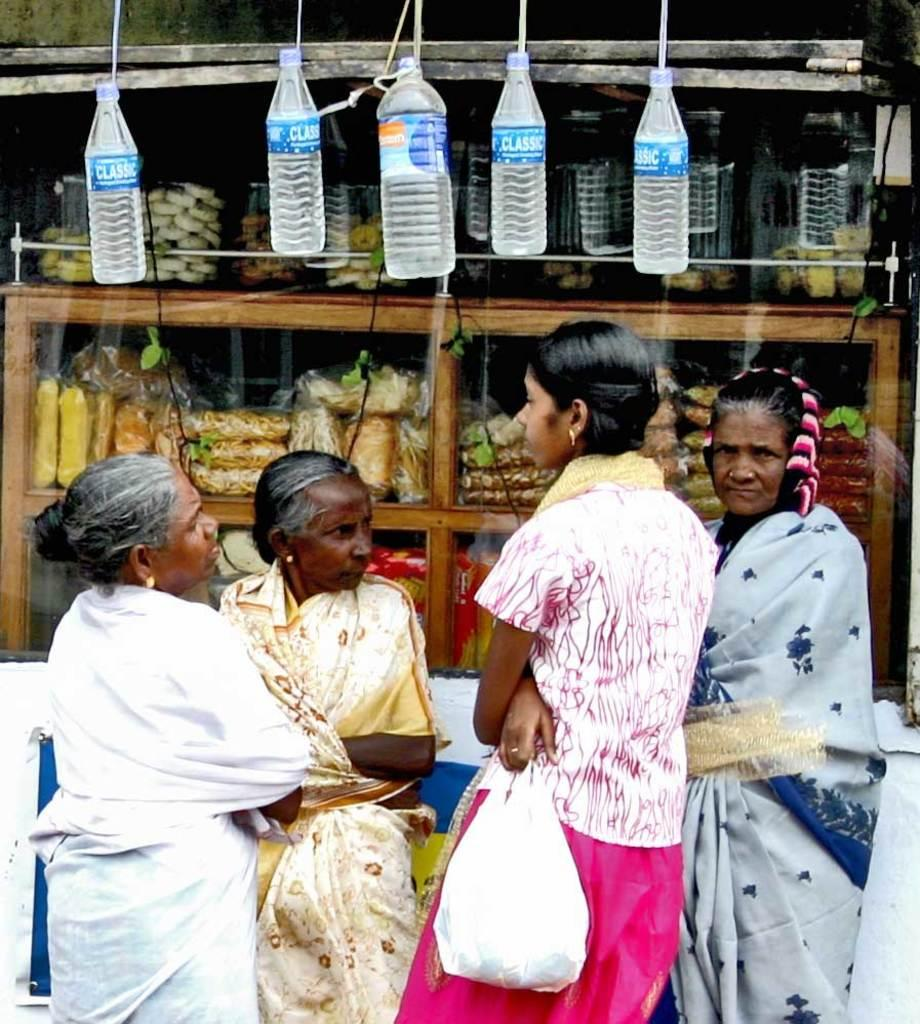How many women are present in the image? There are four women in the image. Where are the women located in the image? The women are standing in the background. What can be seen hanging in the image? There are five bottles hanging in the image. What type of furniture is present in the image? There is a cupboard with food in the image. What type of wound can be seen on the woman's arm in the image? There is no wound visible on any of the women's arms in the image. What is the chance of winning a prize in the image? There is no indication of a prize or any game of chance in the image. 